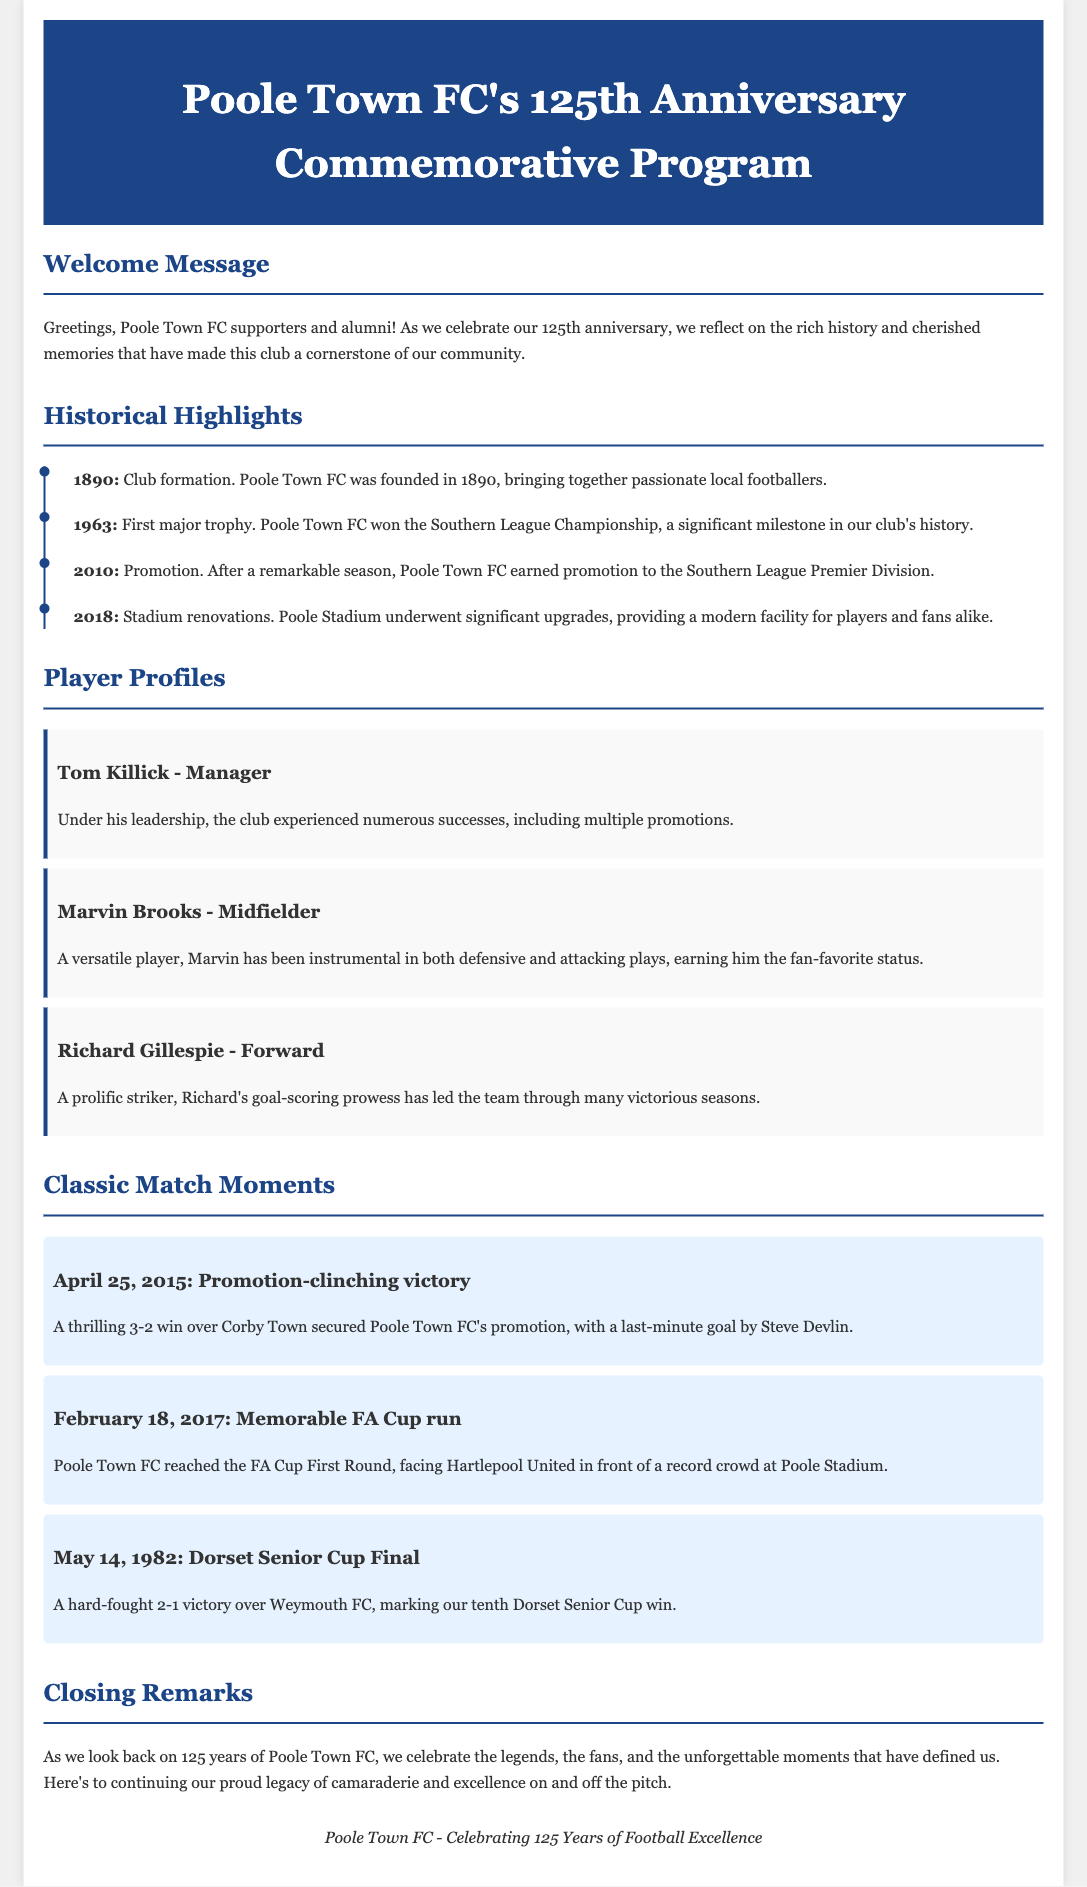What year was Poole Town FC founded? The founding year of Poole Town FC is mentioned as part of the historical highlights in the document.
Answer: 1890 Who was the manager mentioned in the player profiles? The document provides specific player profiles, including the manager.
Answer: Tom Killick What was the score of the promotion-clinching victory match? The match moment for the promotion-clinching victory includes the score.
Answer: 3-2 Which trophy did Poole Town FC win in 1963? The document states the first major trophy won by Poole Town FC as a significant historical highlight.
Answer: Southern League Championship When did Poole Town FC reach the FA Cup First Round? The specific date of this match moment is provided in the document.
Answer: February 18, 2017 What significant event happened in 2018? The timeline includes important milestones, including the specific event in 2018.
Answer: Stadium renovations How many times did Poole Town FC win the Dorset Senior Cup? The document mentions this detail during the classic match moments.
Answer: Ten times What color is the header background in the program? The style section details the color used for the header background.
Answer: #1c4587 What is the title of the commemorative program? The title is found at the top of the document.
Answer: Poole Town FC's 125th Anniversary Commemorative Program 